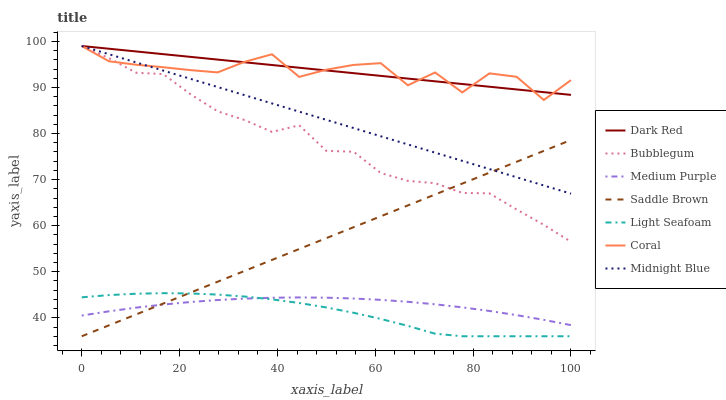Does Light Seafoam have the minimum area under the curve?
Answer yes or no. Yes. Does Dark Red have the maximum area under the curve?
Answer yes or no. Yes. Does Coral have the minimum area under the curve?
Answer yes or no. No. Does Coral have the maximum area under the curve?
Answer yes or no. No. Is Saddle Brown the smoothest?
Answer yes or no. Yes. Is Coral the roughest?
Answer yes or no. Yes. Is Dark Red the smoothest?
Answer yes or no. No. Is Dark Red the roughest?
Answer yes or no. No. Does Coral have the lowest value?
Answer yes or no. No. Does Bubblegum have the highest value?
Answer yes or no. Yes. Does Medium Purple have the highest value?
Answer yes or no. No. Is Saddle Brown less than Coral?
Answer yes or no. Yes. Is Bubblegum greater than Medium Purple?
Answer yes or no. Yes. Does Bubblegum intersect Saddle Brown?
Answer yes or no. Yes. Is Bubblegum less than Saddle Brown?
Answer yes or no. No. Is Bubblegum greater than Saddle Brown?
Answer yes or no. No. Does Saddle Brown intersect Coral?
Answer yes or no. No. 